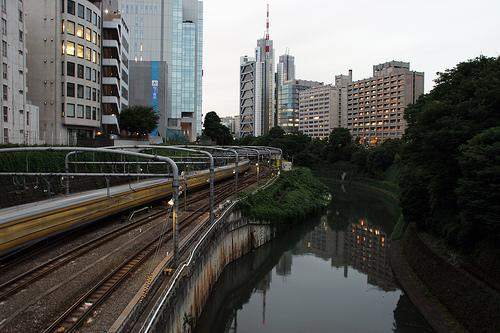List the main objects and elements in the image. Building with numerous windows, train tracks, man made river, skyscraper, vegetation, reflections in the water, green trees and bushes. Give a concise narration of the principal elements in the image. In the image, a multi-windowed building stands alongside train tracks, with a river, green vegetation, and a distant skyscraper creating an urban landscape. Provide a brief description of the primary elements and their locations in the image. There are numerous windows on a building, a man made river, a beacon tower, train tracks, a skyscraper, vegetation, and reflections in the water in various areas of the image. Describe the urban environment captured in the image. The image showcases an urban setting with a building full of windows, train tracks nearby, a man made river, and a distant skyscraper surrounded by greenery. Summarize the scene in the image in a single sentence. The image depicts a cityscape with a multi-windowed building, train tracks, a river, green vegetation, and a skyscraper in the background. Highlight the key features and aspects of the image. The image features a building with many windows, train tracks near the city, a river with reflections, green vegetation, and a skyscraper in the distance. Write a short overview of the main objects in the image and their relation to each other. In the image, a building with many windows is adjacent to train tracks near the city, while a river with reflections and green vegetation separate the tracks from a distant skyscraper. Write a brief statement describing the overall scene in the image. The image shows a city environment characterized by a building with many windows, train tracks nearby, a river, green vegetation, and a skyline featuring a skyscraper. Write a concise summary of the key elements in the image. The image captures a building with multiple windows, train tracks, a river with reflections, vegetation, and a distant skyscraper. Provide a short visual description of the city scene in the image. The city scene consists of a building covered in windows, train tracks, a river with reflections, lush vegetation, and a towering skyscraper in the background. 